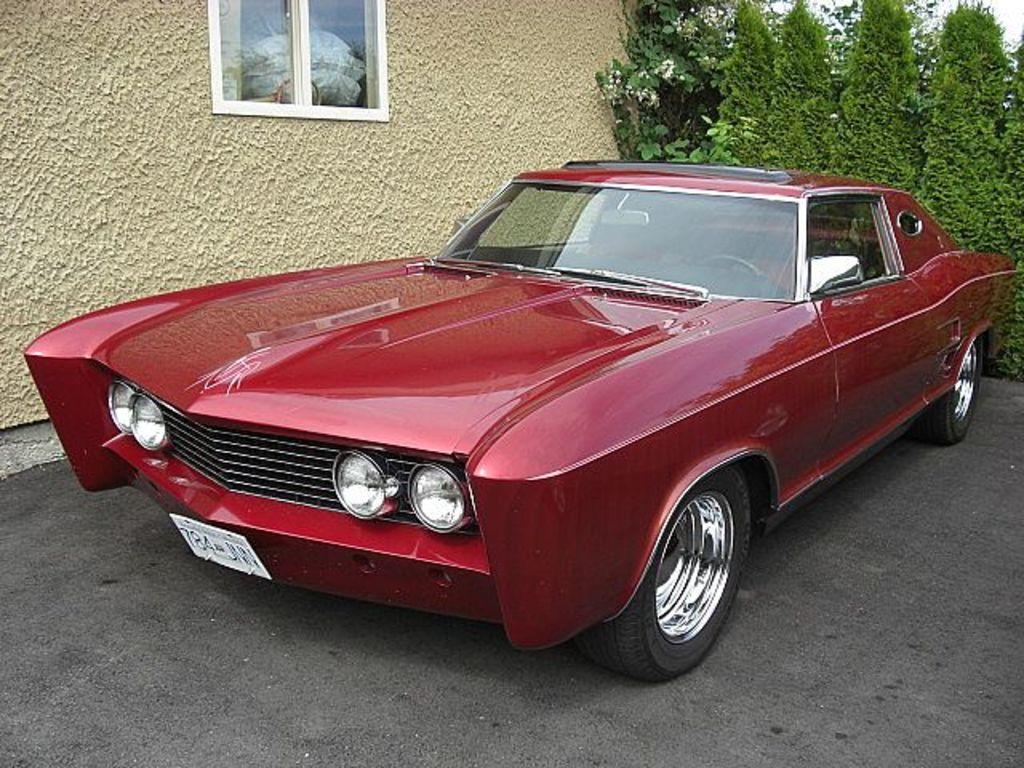Could you give a brief overview of what you see in this image? In this image, we can see a car in front of the wall. There is a window at the top of the image. There are some trees in the top right of the image. 